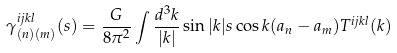Convert formula to latex. <formula><loc_0><loc_0><loc_500><loc_500>\gamma ^ { i j k l } _ { ( n ) ( m ) } ( s ) = \frac { G } { 8 \pi ^ { 2 } } \int \frac { d ^ { 3 } k } { | { k } | } \sin | { k } | s \cos { k } ( { a _ { n } } - { a _ { m } } ) T ^ { i j k l } ( { k } )</formula> 